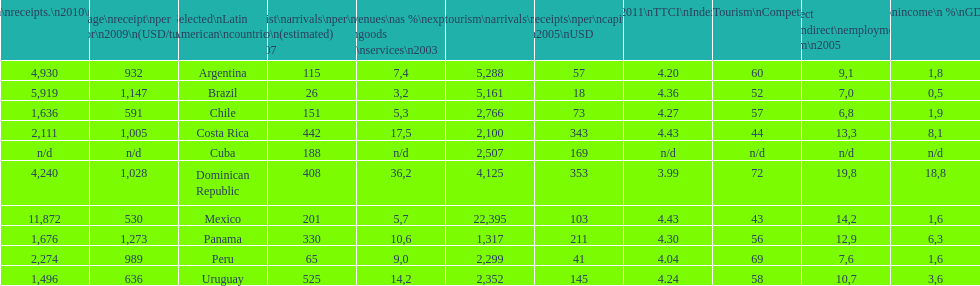How does brazil rank in average receipts per visitor in 2009? 1,147. 